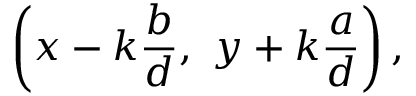Convert formula to latex. <formula><loc_0><loc_0><loc_500><loc_500>\left ( x - k { \frac { b } { d } } , \ y + k { \frac { a } { d } } \right ) ,</formula> 